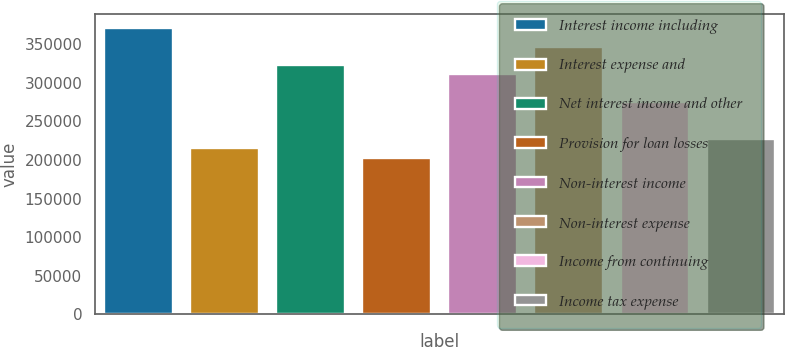Convert chart to OTSL. <chart><loc_0><loc_0><loc_500><loc_500><bar_chart><fcel>Interest income including<fcel>Interest expense and<fcel>Net interest income and other<fcel>Provision for loan losses<fcel>Non-interest income<fcel>Non-interest expense<fcel>Income from continuing<fcel>Income tax expense<nl><fcel>370644<fcel>215213<fcel>322819<fcel>203257<fcel>310862<fcel>346731<fcel>274994<fcel>227169<nl></chart> 